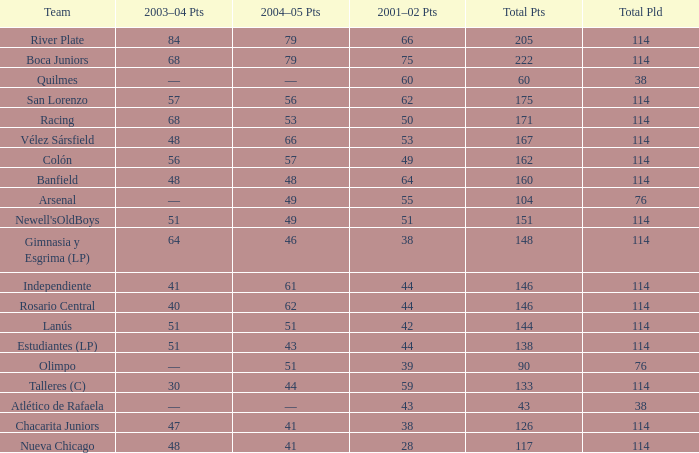Which Total Pts have a 2001–02 Pts smaller than 38? 117.0. 